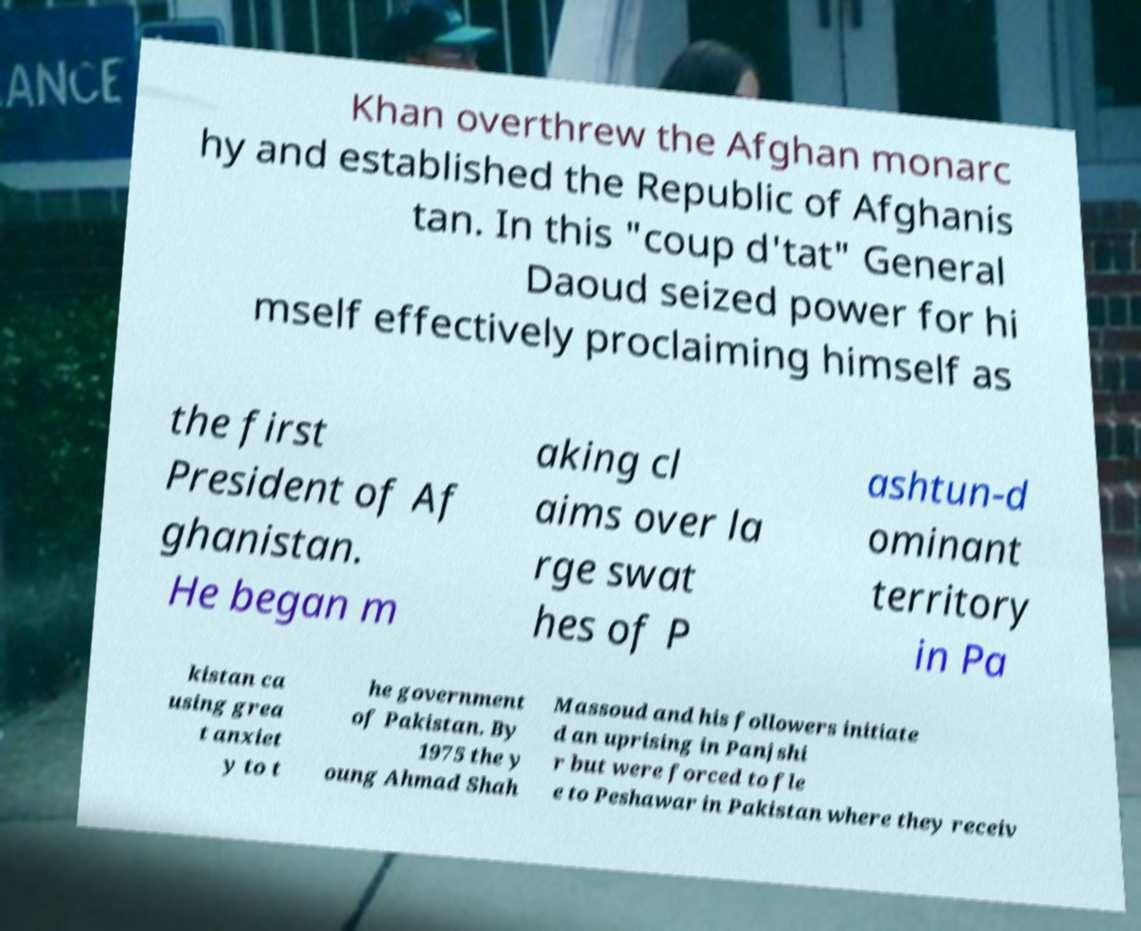Please identify and transcribe the text found in this image. Khan overthrew the Afghan monarc hy and established the Republic of Afghanis tan. In this "coup d'tat" General Daoud seized power for hi mself effectively proclaiming himself as the first President of Af ghanistan. He began m aking cl aims over la rge swat hes of P ashtun-d ominant territory in Pa kistan ca using grea t anxiet y to t he government of Pakistan. By 1975 the y oung Ahmad Shah Massoud and his followers initiate d an uprising in Panjshi r but were forced to fle e to Peshawar in Pakistan where they receiv 